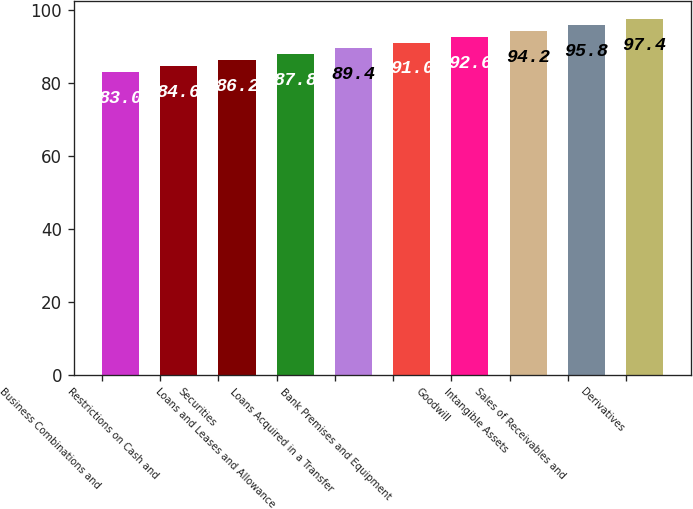Convert chart to OTSL. <chart><loc_0><loc_0><loc_500><loc_500><bar_chart><fcel>Business Combinations and<fcel>Restrictions on Cash and<fcel>Securities<fcel>Loans and Leases and Allowance<fcel>Loans Acquired in a Transfer<fcel>Bank Premises and Equipment<fcel>Goodwill<fcel>Intangible Assets<fcel>Sales of Receivables and<fcel>Derivatives<nl><fcel>83<fcel>84.6<fcel>86.2<fcel>87.8<fcel>89.4<fcel>91<fcel>92.6<fcel>94.2<fcel>95.8<fcel>97.4<nl></chart> 